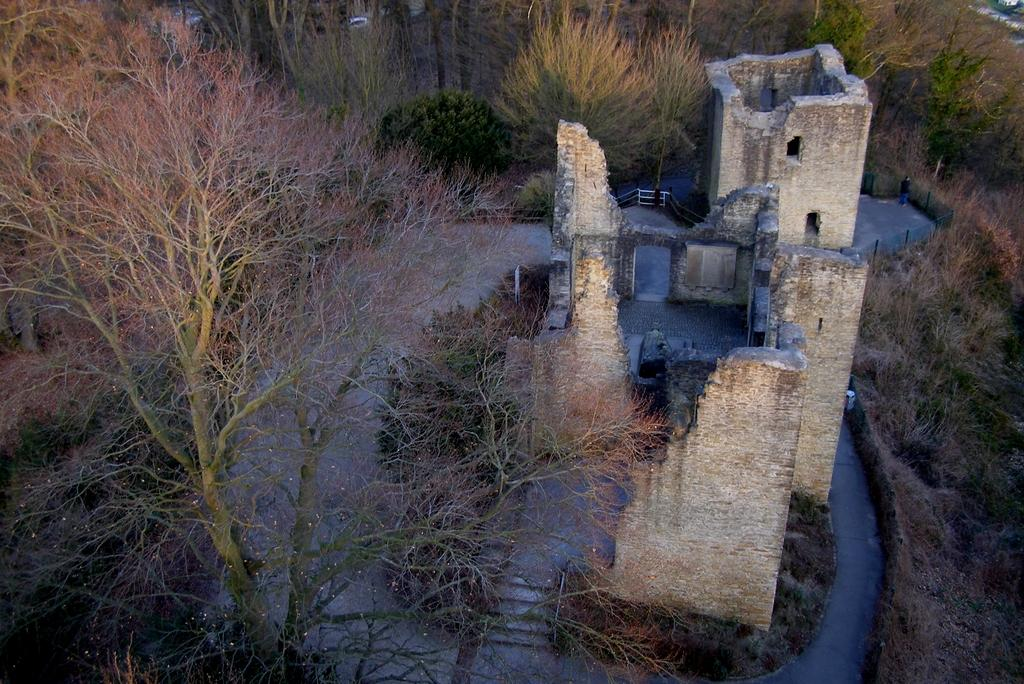What type of structure is visible in the image? There is a building in the image. What other elements can be seen in the image besides the building? There are many plants and trees in the image. Can you describe the vegetation present in the image? The image features a variety of plants and trees. What type of event is taking place in the image involving a donkey? There is no donkey or event present in the image; it features a building and vegetation. 